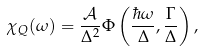<formula> <loc_0><loc_0><loc_500><loc_500>\chi _ { Q } ( \omega ) = \frac { \mathcal { A } } { \Delta ^ { 2 } } \Phi \left ( \frac { \hbar { \omega } } { \Delta } , \frac { \Gamma } { \Delta } \right ) ,</formula> 